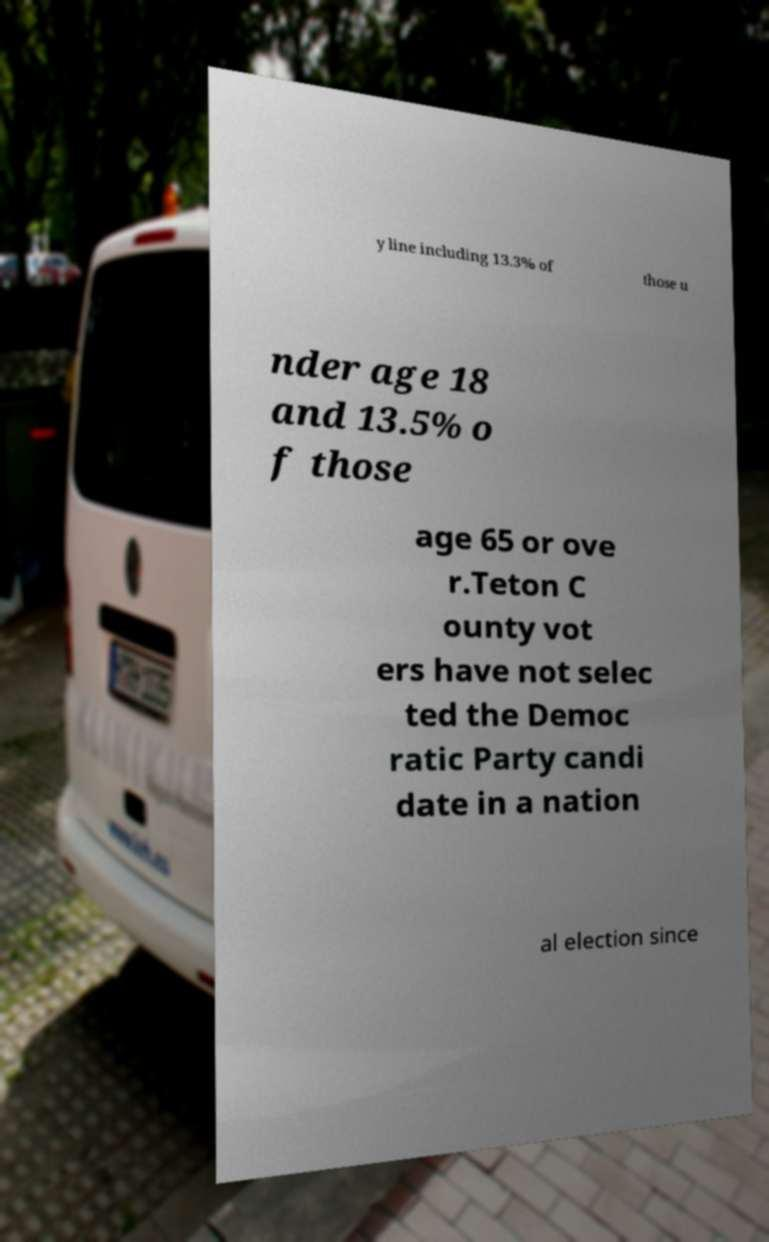Could you assist in decoding the text presented in this image and type it out clearly? y line including 13.3% of those u nder age 18 and 13.5% o f those age 65 or ove r.Teton C ounty vot ers have not selec ted the Democ ratic Party candi date in a nation al election since 